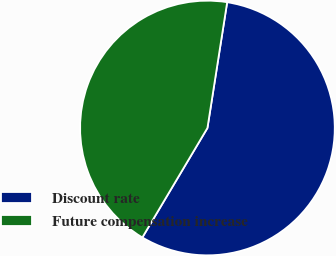Convert chart to OTSL. <chart><loc_0><loc_0><loc_500><loc_500><pie_chart><fcel>Discount rate<fcel>Future compensation increase<nl><fcel>56.06%<fcel>43.94%<nl></chart> 